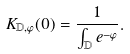Convert formula to latex. <formula><loc_0><loc_0><loc_500><loc_500>K _ { \mathbb { D } , \varphi } ( 0 ) = \frac { 1 } { \int _ { \mathbb { D } } e ^ { - \varphi } } .</formula> 